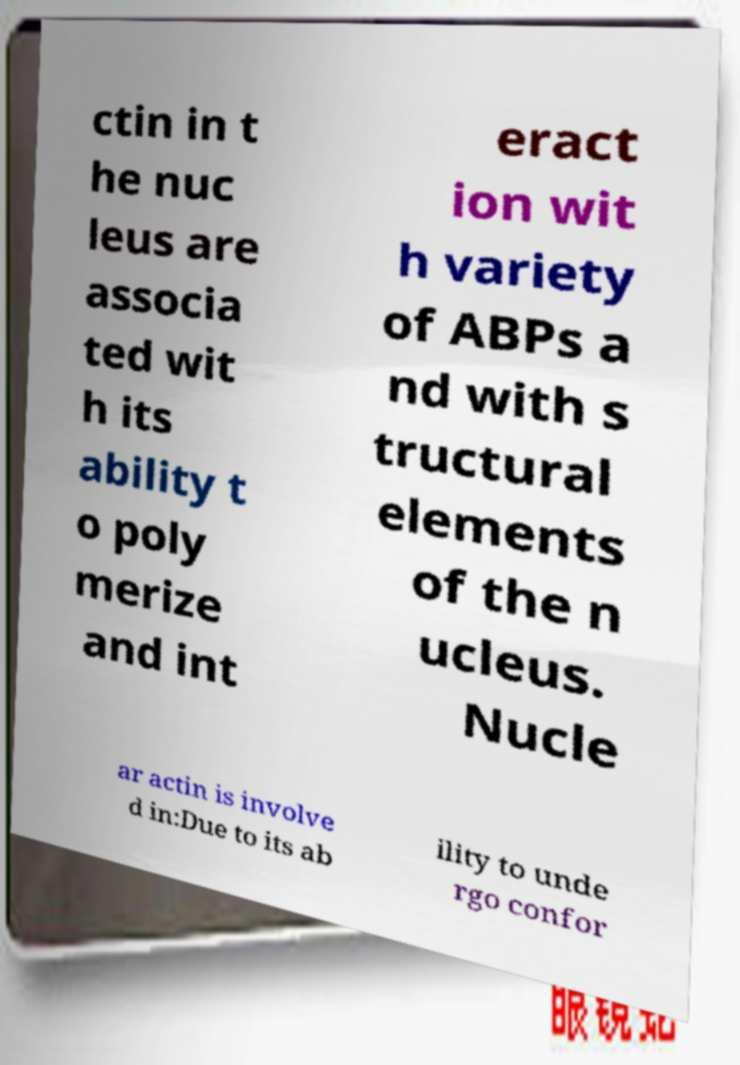There's text embedded in this image that I need extracted. Can you transcribe it verbatim? ctin in t he nuc leus are associa ted wit h its ability t o poly merize and int eract ion wit h variety of ABPs a nd with s tructural elements of the n ucleus. Nucle ar actin is involve d in:Due to its ab ility to unde rgo confor 